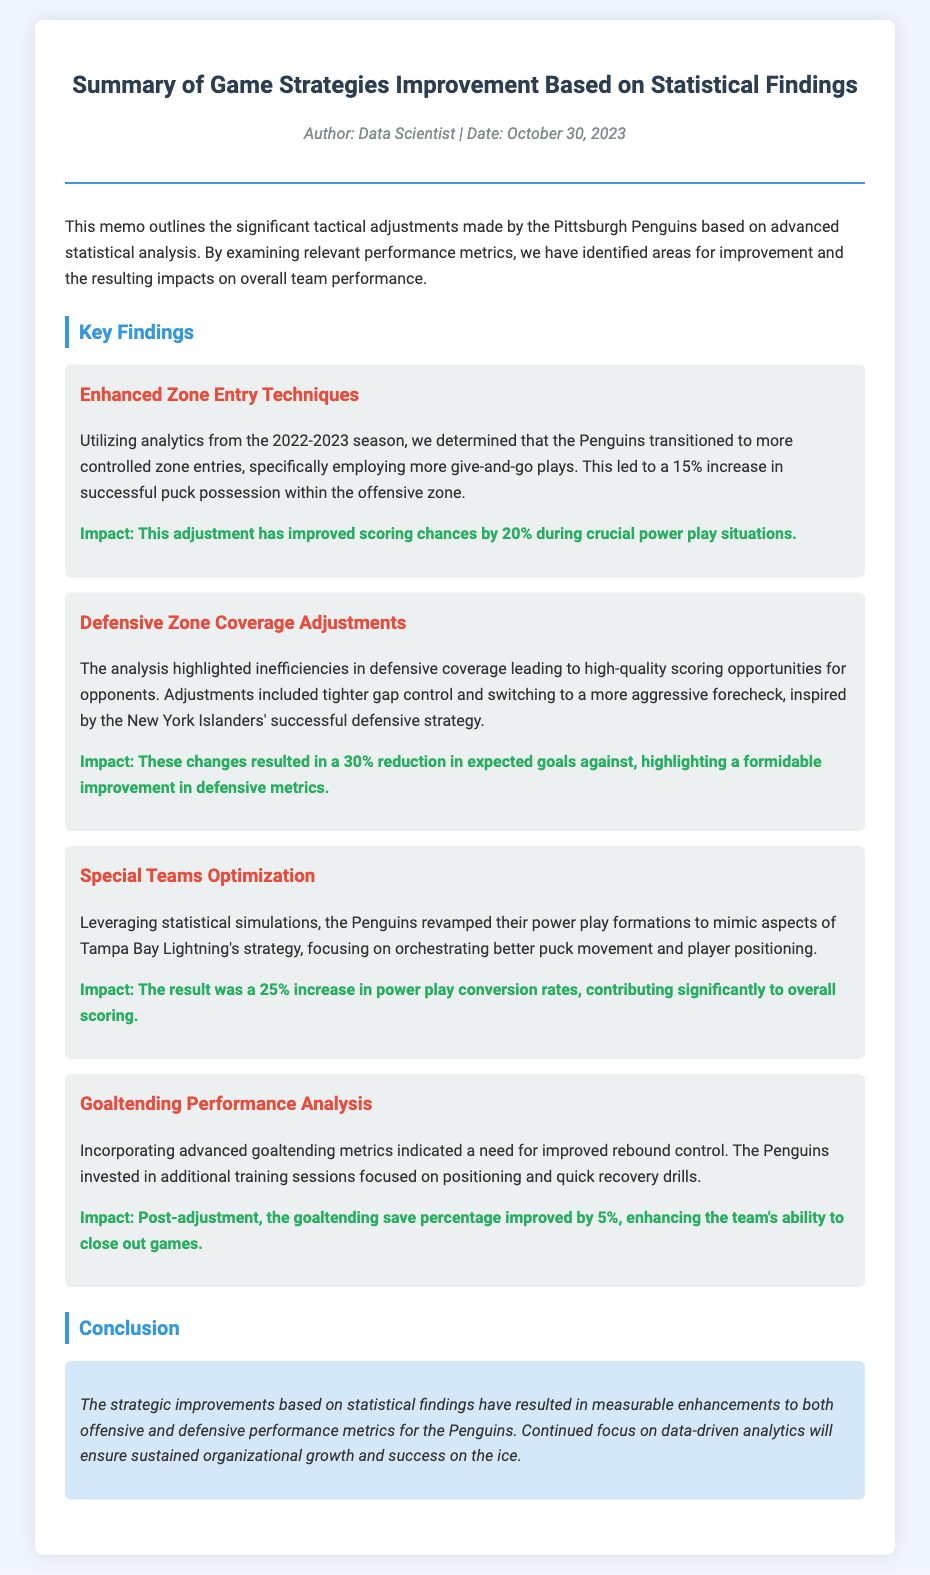What is the title of the memo? The title of the memo is found at the beginning and summarizes the content of the document.
Answer: Summary of Game Strategies Improvement Based on Statistical Findings Who authored the memo? The author information is provided in the memo meta section.
Answer: Data Scientist What date was the memo written? The date can be found in the memo meta section and indicates when it was authored.
Answer: October 30, 2023 What was the percentage increase in successful puck possession from enhanced zone entry techniques? This information is detailed under the first key finding focusing on tactical adjustments.
Answer: 15% What was the reduction in expected goals against due to defensive zone coverage adjustments? This information is provided in the second key finding, discussing the impact of the adjustments on defensive metrics.
Answer: 30% What was the increase in power play conversion rates from special teams optimization? This number can be found in the details of the third key finding along with its strategic background.
Answer: 25% How much did the goaltending save percentage improve by post-adjustment? This improvement is noted under the goaltending performance analysis section, emphasizing the impact of additional training.
Answer: 5% What is the main conclusion of the memo? The conclusion summarizes the overall impact of statistical findings on team performance and future focus.
Answer: Measurable enhancements to both offensive and defensive performance metrics Which successful strategy inspired the Penguins' defensive coverage adjustments? This information can be found in the second key finding, relating to the strategic influences on their defensive maneuvers.
Answer: New York Islanders' 